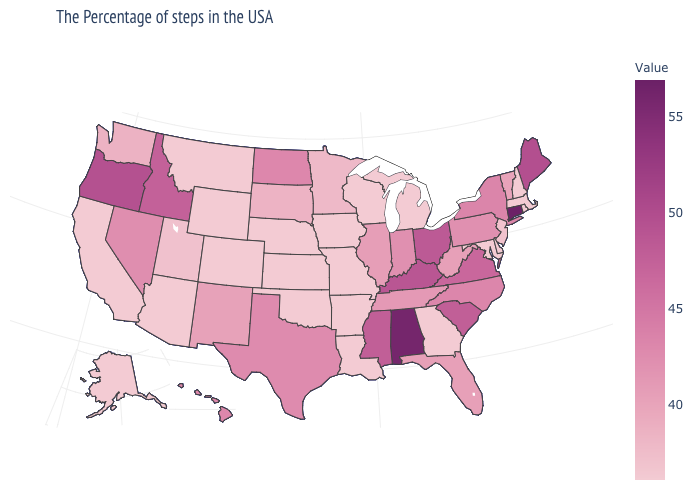Among the states that border New York , does Massachusetts have the lowest value?
Keep it brief. Yes. Does Connecticut have the lowest value in the Northeast?
Concise answer only. No. Does the map have missing data?
Be succinct. No. Does North Carolina have the lowest value in the South?
Keep it brief. No. Which states have the lowest value in the USA?
Concise answer only. Massachusetts, Rhode Island, New Hampshire, Delaware, Maryland, Georgia, Michigan, Wisconsin, Louisiana, Missouri, Arkansas, Iowa, Kansas, Nebraska, Oklahoma, Wyoming, Colorado, Montana, Arizona, California, Alaska. 